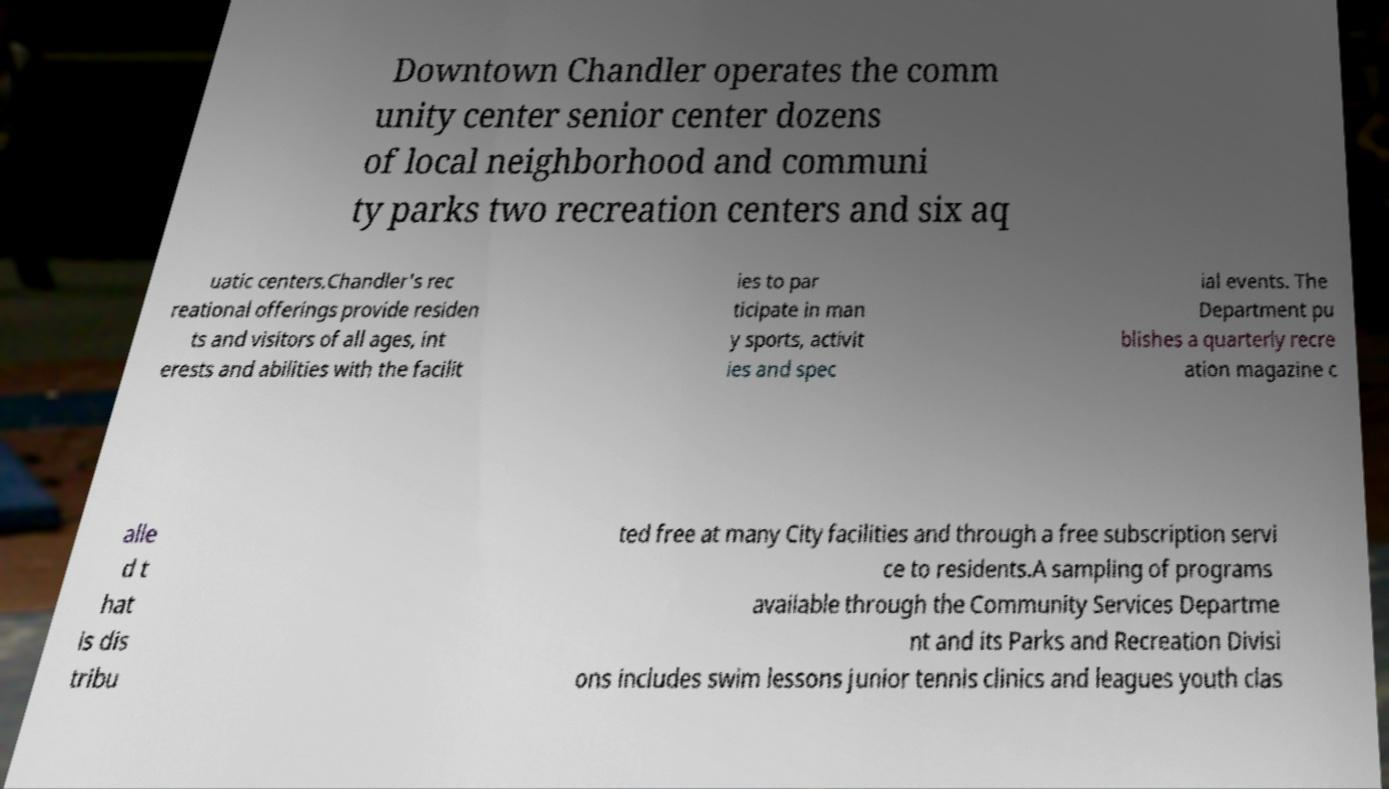There's text embedded in this image that I need extracted. Can you transcribe it verbatim? Downtown Chandler operates the comm unity center senior center dozens of local neighborhood and communi ty parks two recreation centers and six aq uatic centers.Chandler's rec reational offerings provide residen ts and visitors of all ages, int erests and abilities with the facilit ies to par ticipate in man y sports, activit ies and spec ial events. The Department pu blishes a quarterly recre ation magazine c alle d t hat is dis tribu ted free at many City facilities and through a free subscription servi ce to residents.A sampling of programs available through the Community Services Departme nt and its Parks and Recreation Divisi ons includes swim lessons junior tennis clinics and leagues youth clas 